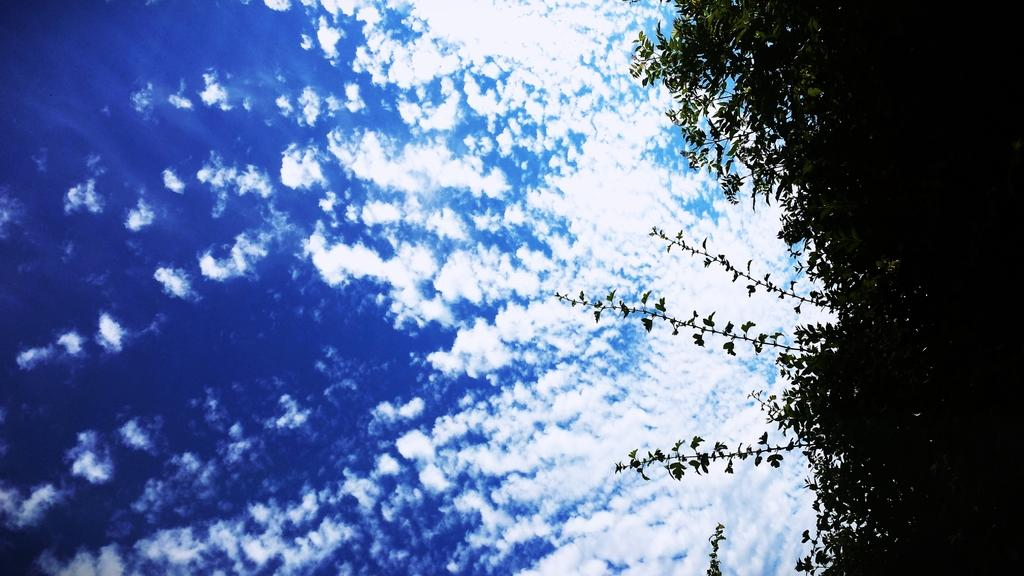What type of vegetation can be seen in the image? There are trees in the image. What part of the natural environment visible in the image? The sky is visible in the image. What can be observed in the sky? Clouds are present in the sky. What type of lamp can be seen hanging from the trees in the image? There is no lamp present in the image; it only features trees and a sky with clouds. 